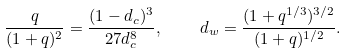<formula> <loc_0><loc_0><loc_500><loc_500>\frac { q } { ( 1 + q ) ^ { 2 } } = \frac { ( 1 - d _ { c } ) ^ { 3 } } { 2 7 d _ { c } ^ { 8 } } , \quad d _ { w } = \frac { ( 1 + q ^ { 1 / 3 } ) ^ { 3 / 2 } } { ( 1 + q ) ^ { 1 / 2 } } .</formula> 